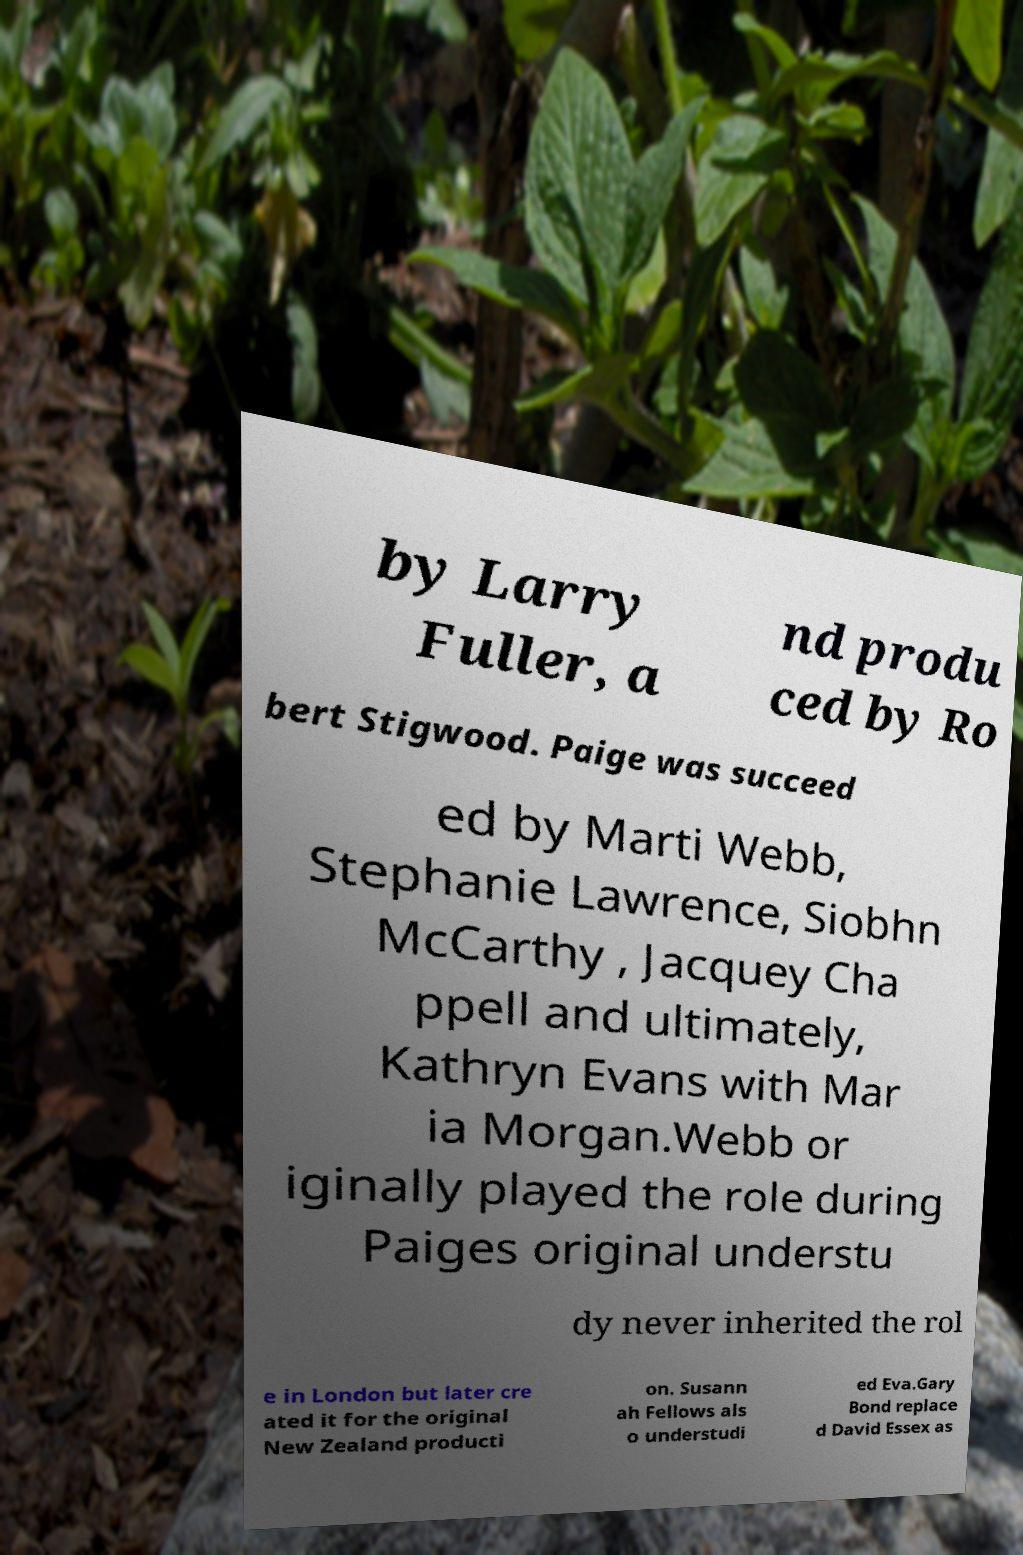I need the written content from this picture converted into text. Can you do that? by Larry Fuller, a nd produ ced by Ro bert Stigwood. Paige was succeed ed by Marti Webb, Stephanie Lawrence, Siobhn McCarthy , Jacquey Cha ppell and ultimately, Kathryn Evans with Mar ia Morgan.Webb or iginally played the role during Paiges original understu dy never inherited the rol e in London but later cre ated it for the original New Zealand producti on. Susann ah Fellows als o understudi ed Eva.Gary Bond replace d David Essex as 